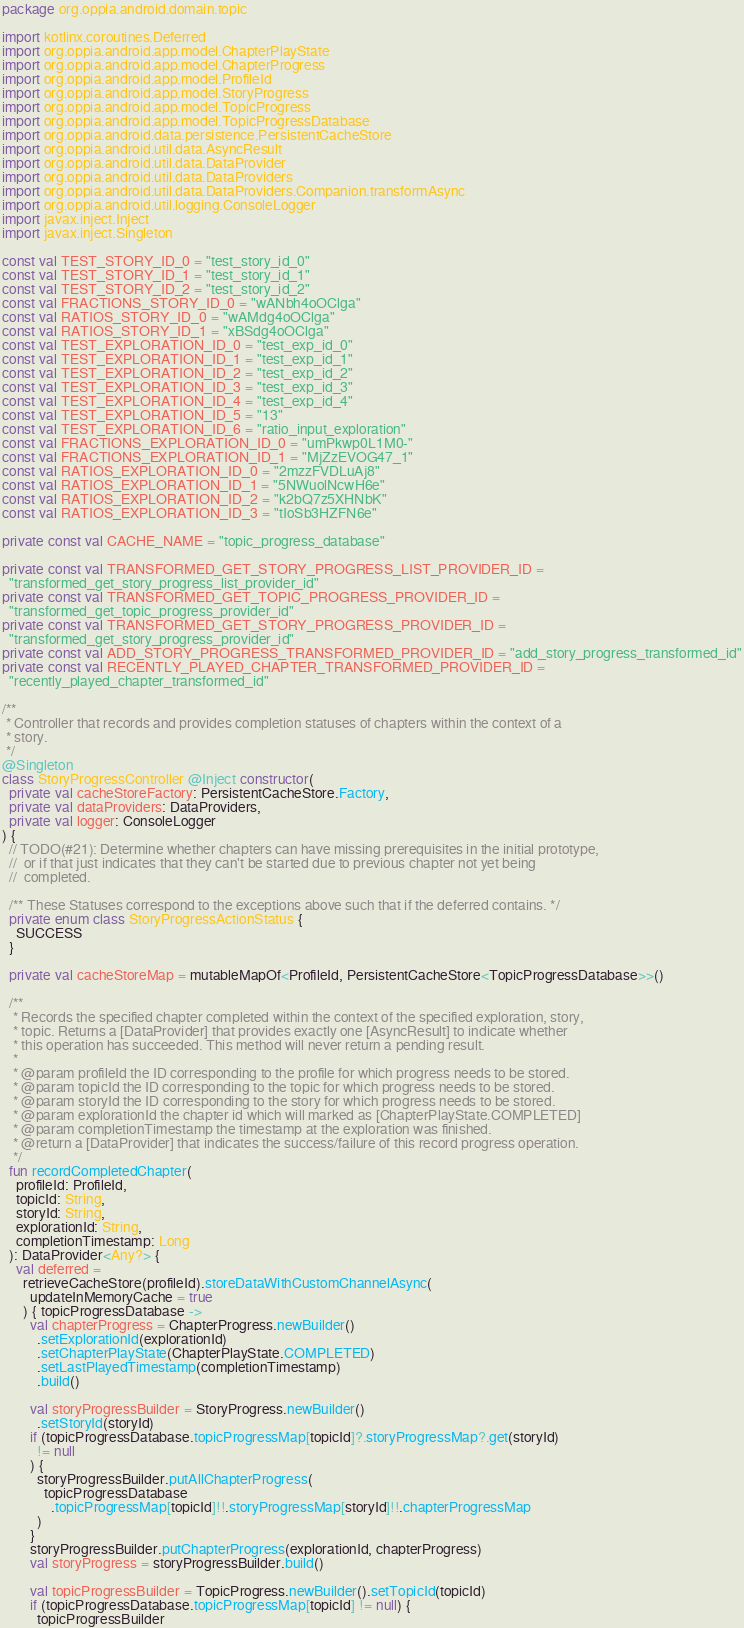Convert code to text. <code><loc_0><loc_0><loc_500><loc_500><_Kotlin_>package org.oppia.android.domain.topic

import kotlinx.coroutines.Deferred
import org.oppia.android.app.model.ChapterPlayState
import org.oppia.android.app.model.ChapterProgress
import org.oppia.android.app.model.ProfileId
import org.oppia.android.app.model.StoryProgress
import org.oppia.android.app.model.TopicProgress
import org.oppia.android.app.model.TopicProgressDatabase
import org.oppia.android.data.persistence.PersistentCacheStore
import org.oppia.android.util.data.AsyncResult
import org.oppia.android.util.data.DataProvider
import org.oppia.android.util.data.DataProviders
import org.oppia.android.util.data.DataProviders.Companion.transformAsync
import org.oppia.android.util.logging.ConsoleLogger
import javax.inject.Inject
import javax.inject.Singleton

const val TEST_STORY_ID_0 = "test_story_id_0"
const val TEST_STORY_ID_1 = "test_story_id_1"
const val TEST_STORY_ID_2 = "test_story_id_2"
const val FRACTIONS_STORY_ID_0 = "wANbh4oOClga"
const val RATIOS_STORY_ID_0 = "wAMdg4oOClga"
const val RATIOS_STORY_ID_1 = "xBSdg4oOClga"
const val TEST_EXPLORATION_ID_0 = "test_exp_id_0"
const val TEST_EXPLORATION_ID_1 = "test_exp_id_1"
const val TEST_EXPLORATION_ID_2 = "test_exp_id_2"
const val TEST_EXPLORATION_ID_3 = "test_exp_id_3"
const val TEST_EXPLORATION_ID_4 = "test_exp_id_4"
const val TEST_EXPLORATION_ID_5 = "13"
const val TEST_EXPLORATION_ID_6 = "ratio_input_exploration"
const val FRACTIONS_EXPLORATION_ID_0 = "umPkwp0L1M0-"
const val FRACTIONS_EXPLORATION_ID_1 = "MjZzEVOG47_1"
const val RATIOS_EXPLORATION_ID_0 = "2mzzFVDLuAj8"
const val RATIOS_EXPLORATION_ID_1 = "5NWuolNcwH6e"
const val RATIOS_EXPLORATION_ID_2 = "k2bQ7z5XHNbK"
const val RATIOS_EXPLORATION_ID_3 = "tIoSb3HZFN6e"

private const val CACHE_NAME = "topic_progress_database"

private const val TRANSFORMED_GET_STORY_PROGRESS_LIST_PROVIDER_ID =
  "transformed_get_story_progress_list_provider_id"
private const val TRANSFORMED_GET_TOPIC_PROGRESS_PROVIDER_ID =
  "transformed_get_topic_progress_provider_id"
private const val TRANSFORMED_GET_STORY_PROGRESS_PROVIDER_ID =
  "transformed_get_story_progress_provider_id"
private const val ADD_STORY_PROGRESS_TRANSFORMED_PROVIDER_ID = "add_story_progress_transformed_id"
private const val RECENTLY_PLAYED_CHAPTER_TRANSFORMED_PROVIDER_ID =
  "recently_played_chapter_transformed_id"

/**
 * Controller that records and provides completion statuses of chapters within the context of a
 * story.
 */
@Singleton
class StoryProgressController @Inject constructor(
  private val cacheStoreFactory: PersistentCacheStore.Factory,
  private val dataProviders: DataProviders,
  private val logger: ConsoleLogger
) {
  // TODO(#21): Determine whether chapters can have missing prerequisites in the initial prototype,
  //  or if that just indicates that they can't be started due to previous chapter not yet being
  //  completed.

  /** These Statuses correspond to the exceptions above such that if the deferred contains. */
  private enum class StoryProgressActionStatus {
    SUCCESS
  }

  private val cacheStoreMap = mutableMapOf<ProfileId, PersistentCacheStore<TopicProgressDatabase>>()

  /**
   * Records the specified chapter completed within the context of the specified exploration, story,
   * topic. Returns a [DataProvider] that provides exactly one [AsyncResult] to indicate whether
   * this operation has succeeded. This method will never return a pending result.
   *
   * @param profileId the ID corresponding to the profile for which progress needs to be stored.
   * @param topicId the ID corresponding to the topic for which progress needs to be stored.
   * @param storyId the ID corresponding to the story for which progress needs to be stored.
   * @param explorationId the chapter id which will marked as [ChapterPlayState.COMPLETED]
   * @param completionTimestamp the timestamp at the exploration was finished.
   * @return a [DataProvider] that indicates the success/failure of this record progress operation.
   */
  fun recordCompletedChapter(
    profileId: ProfileId,
    topicId: String,
    storyId: String,
    explorationId: String,
    completionTimestamp: Long
  ): DataProvider<Any?> {
    val deferred =
      retrieveCacheStore(profileId).storeDataWithCustomChannelAsync(
        updateInMemoryCache = true
      ) { topicProgressDatabase ->
        val chapterProgress = ChapterProgress.newBuilder()
          .setExplorationId(explorationId)
          .setChapterPlayState(ChapterPlayState.COMPLETED)
          .setLastPlayedTimestamp(completionTimestamp)
          .build()

        val storyProgressBuilder = StoryProgress.newBuilder()
          .setStoryId(storyId)
        if (topicProgressDatabase.topicProgressMap[topicId]?.storyProgressMap?.get(storyId)
          != null
        ) {
          storyProgressBuilder.putAllChapterProgress(
            topicProgressDatabase
              .topicProgressMap[topicId]!!.storyProgressMap[storyId]!!.chapterProgressMap
          )
        }
        storyProgressBuilder.putChapterProgress(explorationId, chapterProgress)
        val storyProgress = storyProgressBuilder.build()

        val topicProgressBuilder = TopicProgress.newBuilder().setTopicId(topicId)
        if (topicProgressDatabase.topicProgressMap[topicId] != null) {
          topicProgressBuilder</code> 